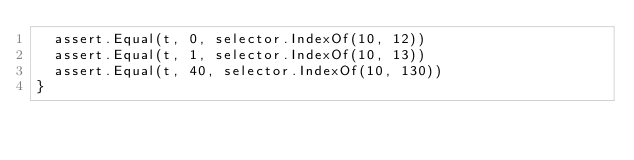Convert code to text. <code><loc_0><loc_0><loc_500><loc_500><_Go_>	assert.Equal(t, 0, selector.IndexOf(10, 12))
	assert.Equal(t, 1, selector.IndexOf(10, 13))
	assert.Equal(t, 40, selector.IndexOf(10, 130))
}
</code> 